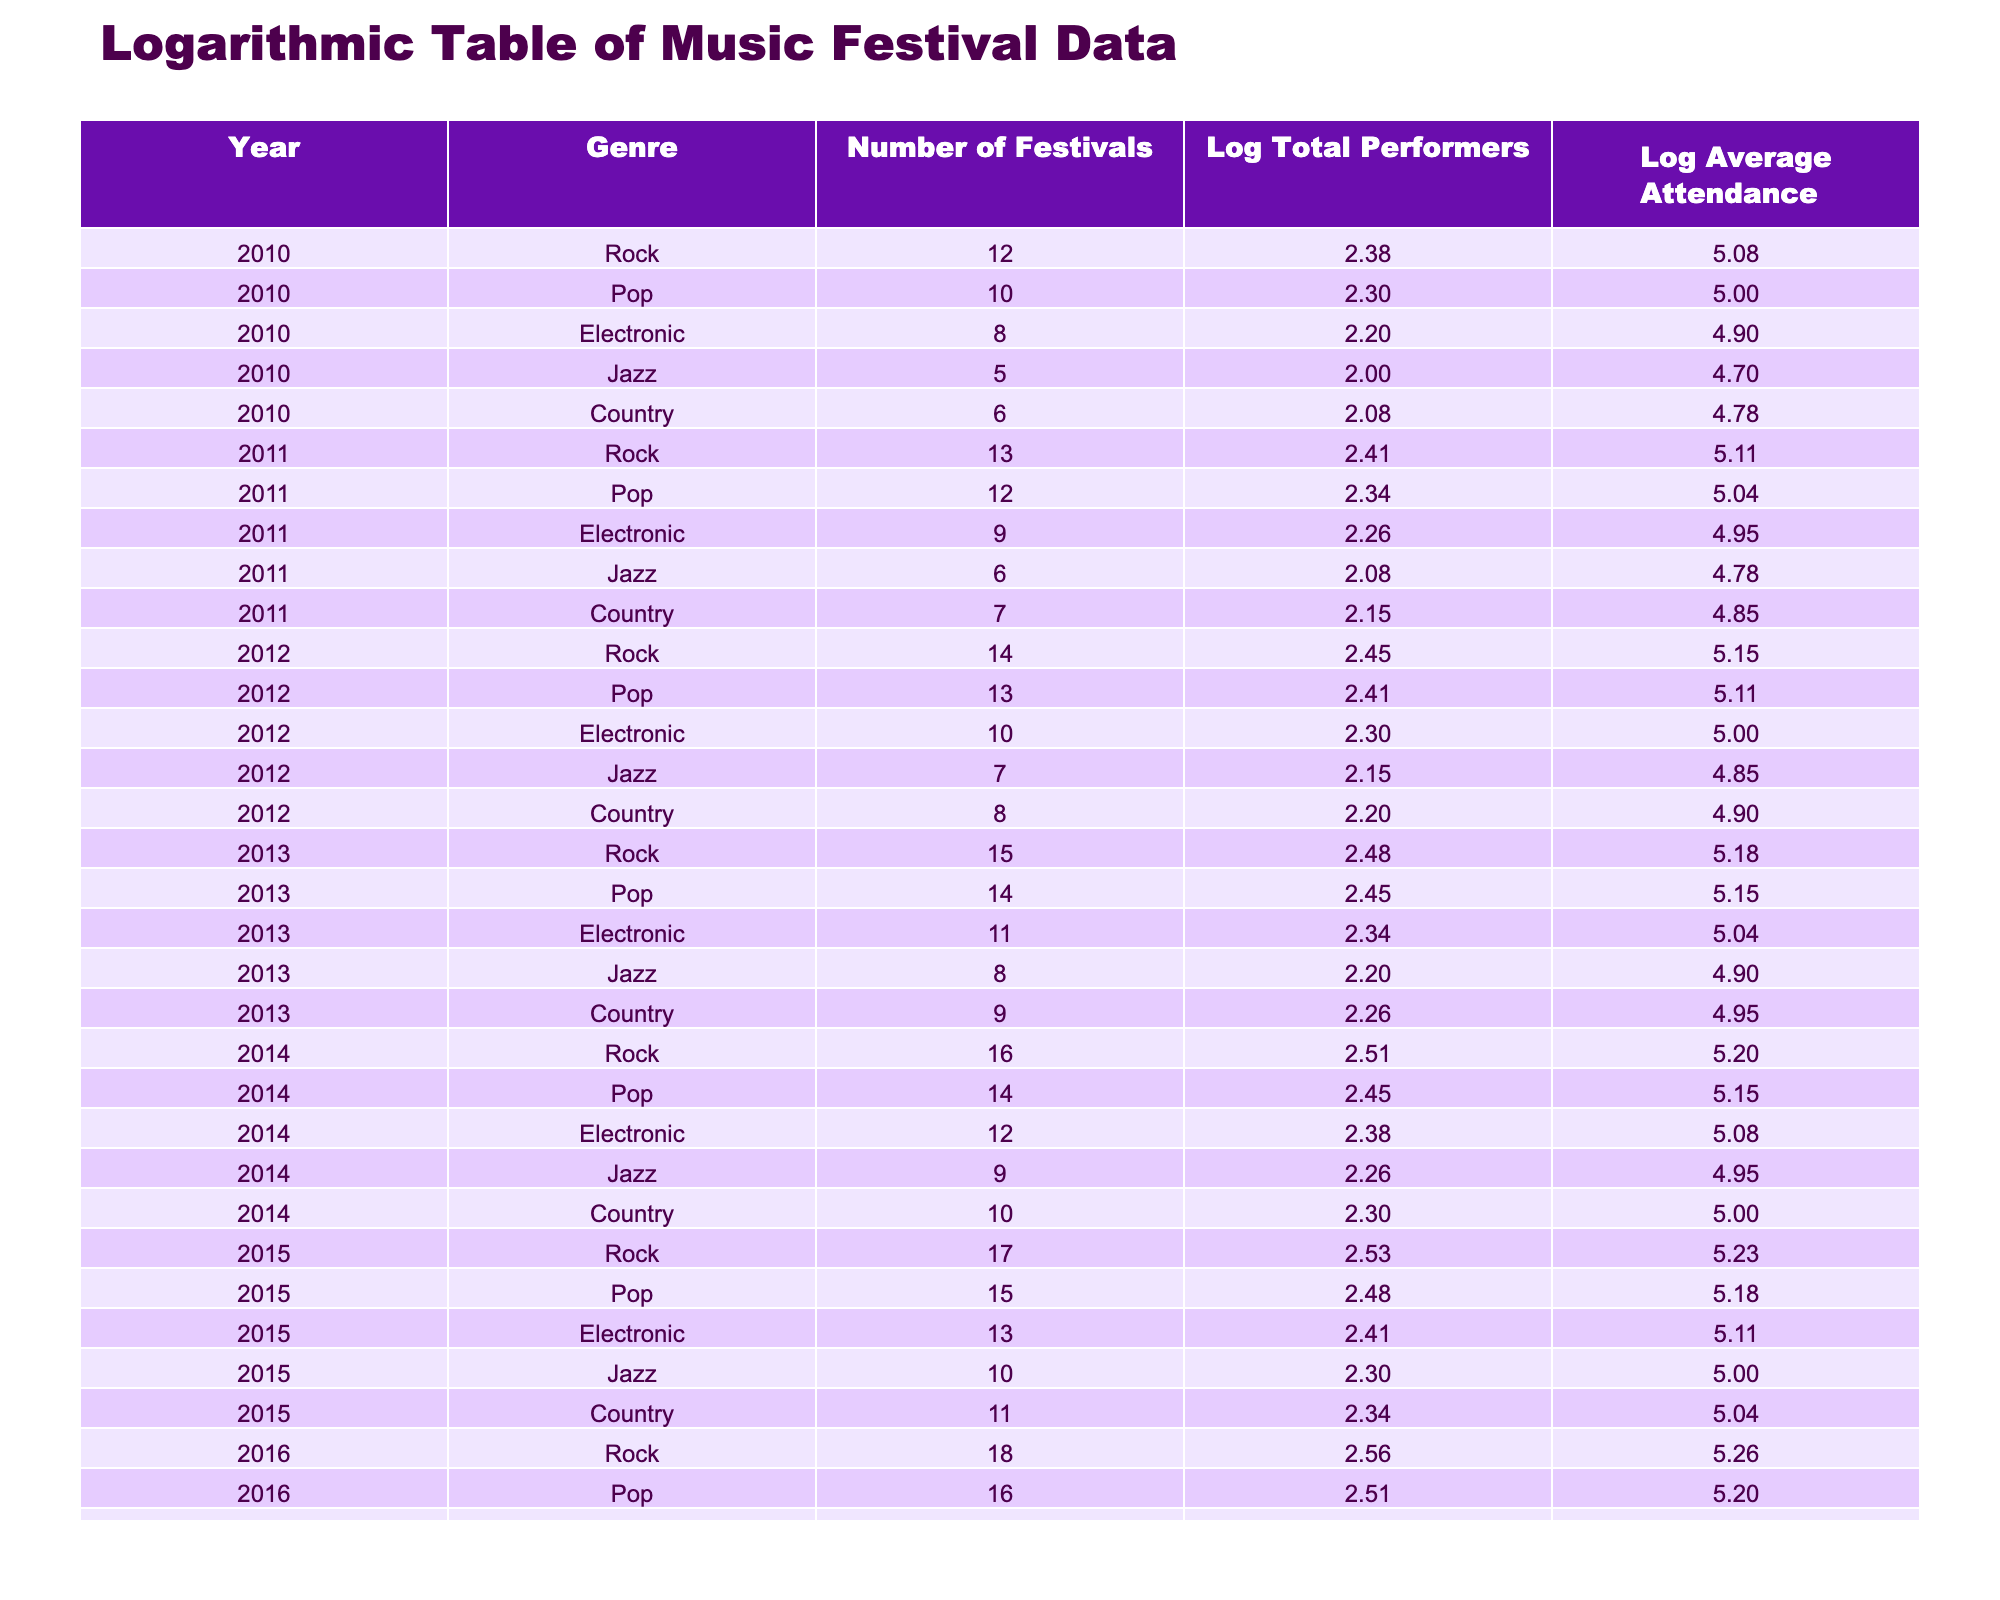What was the total number of performers for Electronic music in 2013? In 2013, the total number of performers for Electronic music is explicitly listed in the table, which is 220.
Answer: 220 What is the average attendance for Pop music in 2012? The table directly shows the average attendance for Pop music in 2012 as 130,000.
Answer: 130000 How many festivals represented Jazz music over the years displayed? To find the total number of festivals for Jazz music, I add the 'Number of Festivals' for each year listed under the Jazz genre: 5 + 6 + 7 + 8 + 9 + 10 = 45.
Answer: 45 Which genre had the highest logarithmic value for total performers in 2015? From the table, the logarithmic value of total performers is 2.53 for Rock (340 performers), which is higher than the other genres for 2015.
Answer: Rock Was the average attendance for Country music higher in 2015 than in 2014? In the table, the average attendance for Country music in 2015 is 110,000 and in 2014 it is 100,000. Therefore, it is higher in 2015.
Answer: Yes What was the increase in the logarithmic value of average attendance for Electronic music from 2010 to 2016? The logarithmic value of average attendance for Electronic music in 2010 is 4.90 (80,000) and in 2016 is 5.15 (140,000). The increase is calculated as 5.15 - 4.90 = 0.25.
Answer: 0.25 What genre showed the least total performers in any year from 2010 to 2016? By examining the table, the 'Total Performers' for Jazz in 2010 is the least at 100 performers.
Answer: Jazz Which year saw the greatest number of festivals for Rock music? Looking at the 'Number of Festivals' under the Rock genre, 2016 has the highest count at 18 festivals.
Answer: 2016 What trend can be observed in the number of festivals for Pop music from 2010 to 2016? Reviewing the table shows that the number of festivals for Pop music has increased consistently from 10 in 2010 to 16 in 2016.
Answer: Increasing trend 